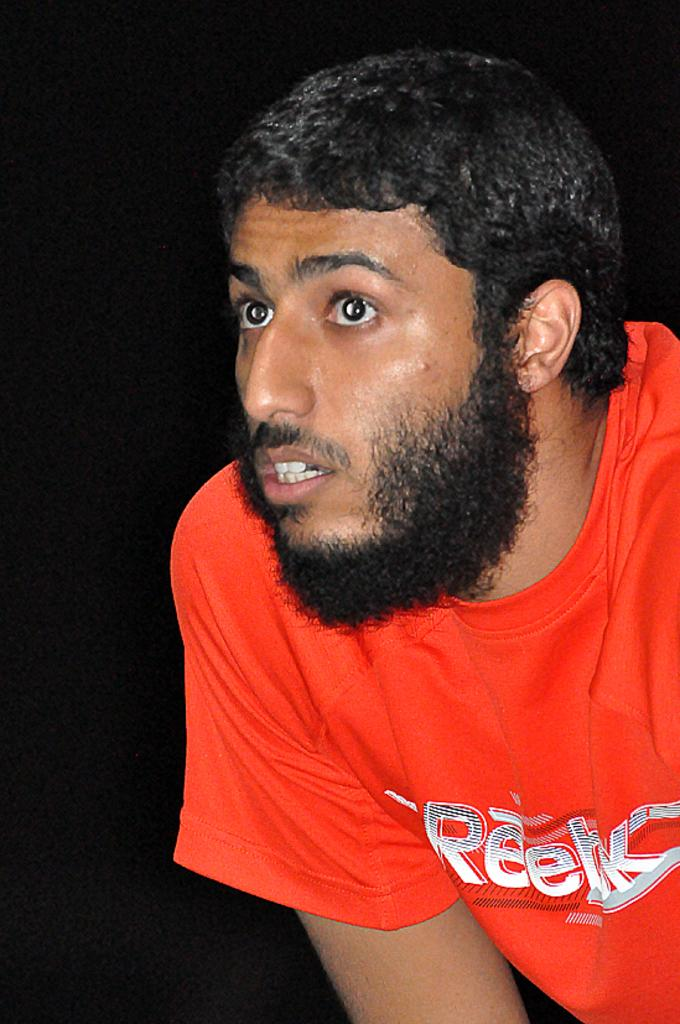Who is the main subject in the picture? There is a man in the picture. Where is the man located in the image? The man is in the middle of the picture. What is the man wearing in the image? The man is wearing a red T-shirt. What can be observed about the background of the image? The background of the image is dark. What type of curtain is hanging in the image? There is no curtain present in the image. What part of the man's body is exposed in the image? The image only shows the man wearing a red T-shirt, so no flesh is visible. 